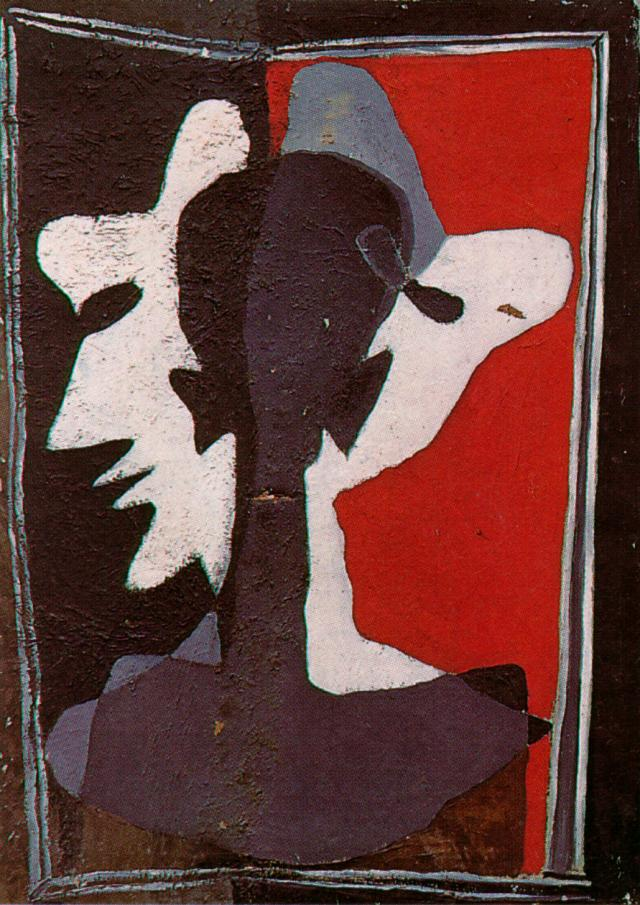How would you describe the technique used in this artwork? The artwork employs techniques characteristic of abstract and expressionist styles. The use of bold color contrasts and layered silhouettes creates a sense of depth and dimension. The rough texture of the paint adds to the emotional intensity, suggesting an unrefined, raw expression of the artist's vision. The composition relies heavily on the interplay of positive and negative spaces, drawing the viewer's eye to the center of the piece where the forms converge and diverge. The geometric simplicity combined with complex layering techniques creates a dynamic visual experience. 